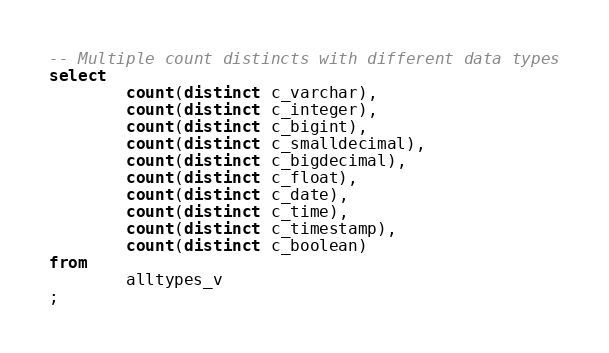Convert code to text. <code><loc_0><loc_0><loc_500><loc_500><_SQL_>-- Multiple count distincts with different data types
select
        count(distinct c_varchar),
        count(distinct c_integer),
        count(distinct c_bigint),
        count(distinct c_smalldecimal),
        count(distinct c_bigdecimal),
        count(distinct c_float),
        count(distinct c_date),
        count(distinct c_time),
        count(distinct c_timestamp),
        count(distinct c_boolean)
from
        alltypes_v
;

</code> 